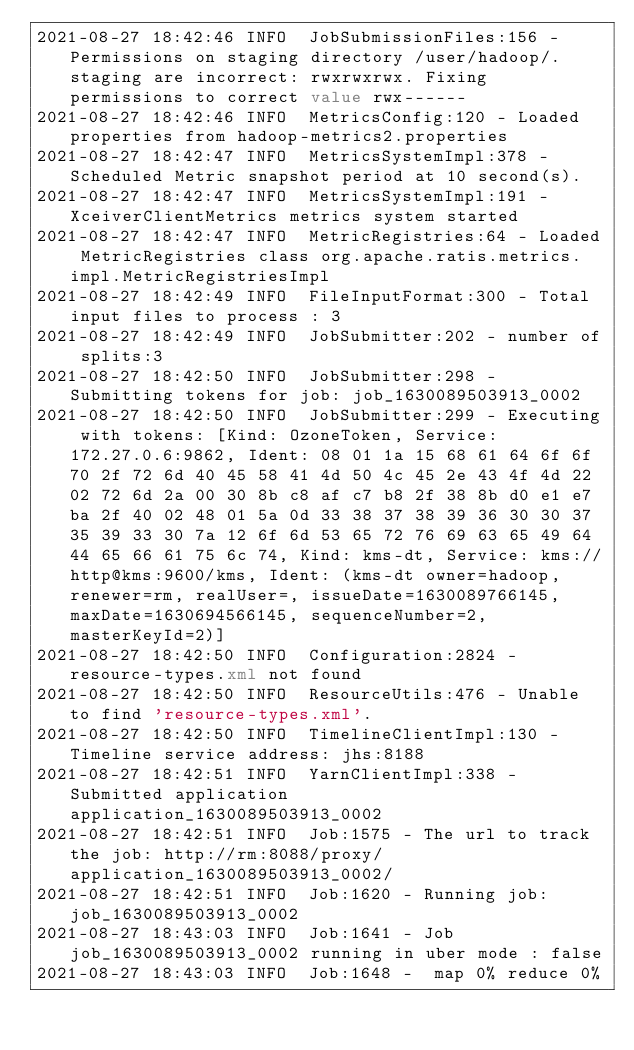Convert code to text. <code><loc_0><loc_0><loc_500><loc_500><_XML_>2021-08-27 18:42:46 INFO  JobSubmissionFiles:156 - Permissions on staging directory /user/hadoop/.staging are incorrect: rwxrwxrwx. Fixing permissions to correct value rwx------
2021-08-27 18:42:46 INFO  MetricsConfig:120 - Loaded properties from hadoop-metrics2.properties
2021-08-27 18:42:47 INFO  MetricsSystemImpl:378 - Scheduled Metric snapshot period at 10 second(s).
2021-08-27 18:42:47 INFO  MetricsSystemImpl:191 - XceiverClientMetrics metrics system started
2021-08-27 18:42:47 INFO  MetricRegistries:64 - Loaded MetricRegistries class org.apache.ratis.metrics.impl.MetricRegistriesImpl
2021-08-27 18:42:49 INFO  FileInputFormat:300 - Total input files to process : 3
2021-08-27 18:42:49 INFO  JobSubmitter:202 - number of splits:3
2021-08-27 18:42:50 INFO  JobSubmitter:298 - Submitting tokens for job: job_1630089503913_0002
2021-08-27 18:42:50 INFO  JobSubmitter:299 - Executing with tokens: [Kind: OzoneToken, Service: 172.27.0.6:9862, Ident: 08 01 1a 15 68 61 64 6f 6f 70 2f 72 6d 40 45 58 41 4d 50 4c 45 2e 43 4f 4d 22 02 72 6d 2a 00 30 8b c8 af c7 b8 2f 38 8b d0 e1 e7 ba 2f 40 02 48 01 5a 0d 33 38 37 38 39 36 30 30 37 35 39 33 30 7a 12 6f 6d 53 65 72 76 69 63 65 49 64 44 65 66 61 75 6c 74, Kind: kms-dt, Service: kms://http@kms:9600/kms, Ident: (kms-dt owner=hadoop, renewer=rm, realUser=, issueDate=1630089766145, maxDate=1630694566145, sequenceNumber=2, masterKeyId=2)]
2021-08-27 18:42:50 INFO  Configuration:2824 - resource-types.xml not found
2021-08-27 18:42:50 INFO  ResourceUtils:476 - Unable to find 'resource-types.xml'.
2021-08-27 18:42:50 INFO  TimelineClientImpl:130 - Timeline service address: jhs:8188
2021-08-27 18:42:51 INFO  YarnClientImpl:338 - Submitted application application_1630089503913_0002
2021-08-27 18:42:51 INFO  Job:1575 - The url to track the job: http://rm:8088/proxy/application_1630089503913_0002/
2021-08-27 18:42:51 INFO  Job:1620 - Running job: job_1630089503913_0002
2021-08-27 18:43:03 INFO  Job:1641 - Job job_1630089503913_0002 running in uber mode : false
2021-08-27 18:43:03 INFO  Job:1648 -  map 0% reduce 0%</code> 